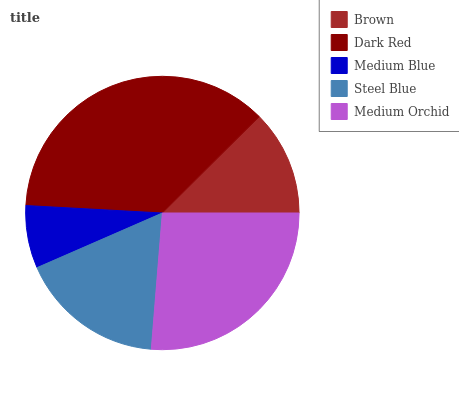Is Medium Blue the minimum?
Answer yes or no. Yes. Is Dark Red the maximum?
Answer yes or no. Yes. Is Dark Red the minimum?
Answer yes or no. No. Is Medium Blue the maximum?
Answer yes or no. No. Is Dark Red greater than Medium Blue?
Answer yes or no. Yes. Is Medium Blue less than Dark Red?
Answer yes or no. Yes. Is Medium Blue greater than Dark Red?
Answer yes or no. No. Is Dark Red less than Medium Blue?
Answer yes or no. No. Is Steel Blue the high median?
Answer yes or no. Yes. Is Steel Blue the low median?
Answer yes or no. Yes. Is Medium Orchid the high median?
Answer yes or no. No. Is Brown the low median?
Answer yes or no. No. 